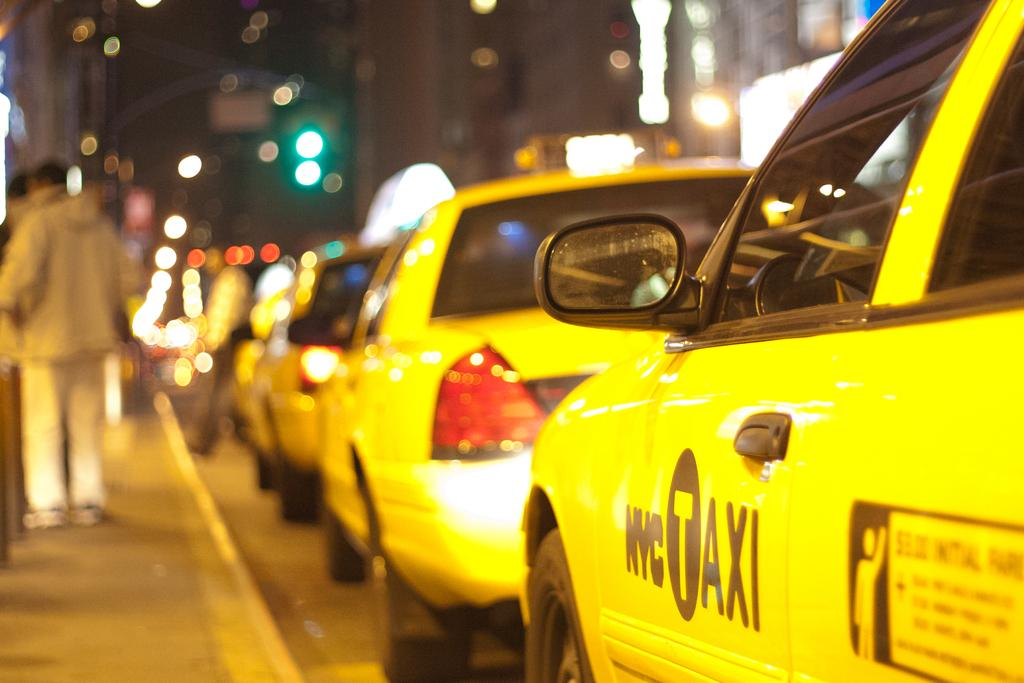<image>
Describe the image concisely. A busy street has a line of taxis along the curb with the nearest one being a NYC Taxi. 